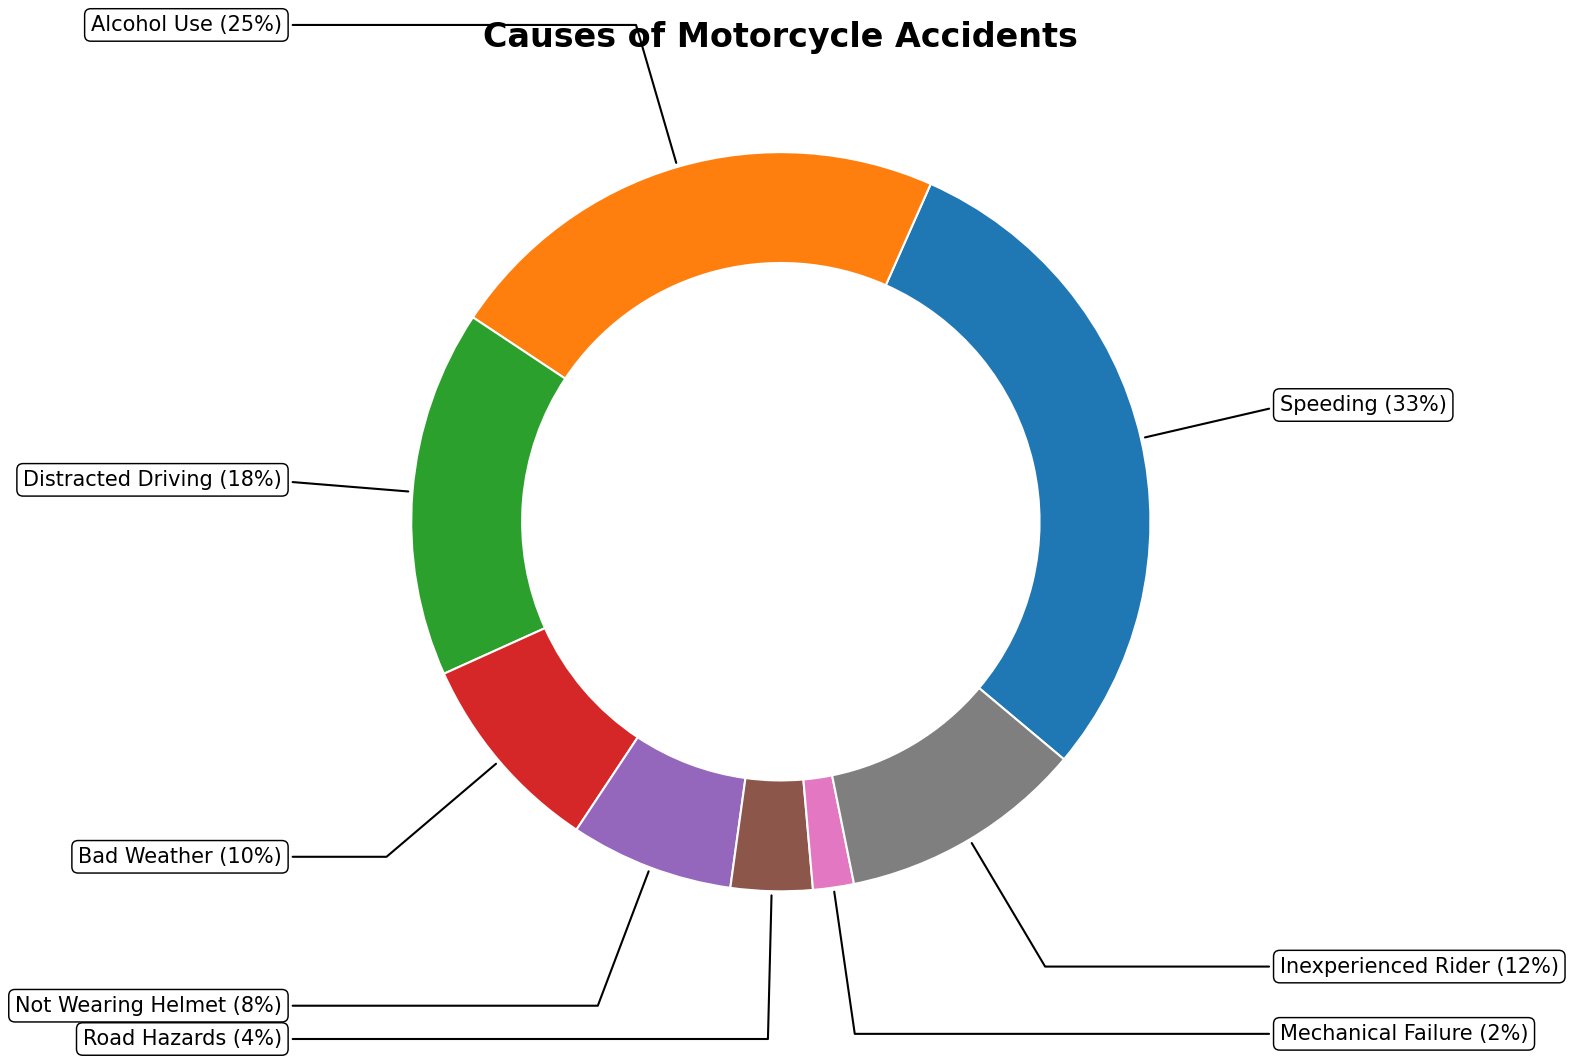What percentage of motorcycle accidents is caused by alcohol use? The segment of the chart labeled "Alcohol Use" represents the portion of accidents caused by alcohol use. According to the figure, this segment is marked with 25%.
Answer: 25% Which cause accounts for the highest percentage of motorcycle accidents? By examining the segments of the ring chart, the segment labeled "Speeding" occupies the largest portion. It is annotated with 33%, signifying it has the highest percentage.
Answer: Speeding Compare the percentages of "Distracted Driving" and "Inexperienced Rider." Which one is higher? Locate the segments for "Distracted Driving" and "Inexperienced Rider" in the chart. "Distracted Driving" is marked with 18%, while "Inexperienced Rider" is marked with 12%. Therefore, "Distracted Driving" is higher.
Answer: Distracted Driving What is the combined percentage of accidents caused by "Bad Weather" and "Not Wearing Helmet"? Find the segments for "Bad Weather" and "Not Wearing Helmet" in the ring chart. "Bad Weather" is marked with 10% and "Not Wearing Helmet" with 8%. The combined percentage is 10% + 8% = 18%.
Answer: 18% Is the percentage of accidents caused by "Mechanical Failure" greater than, less than, or equal to "Road Hazards"? Identify the segments for "Mechanical Failure" and "Road Hazards". "Mechanical Failure" is marked with 2% and "Road Hazards" with 4%. Therefore, "Mechanical Failure" is less than "Road Hazards".
Answer: Less than What are the three least common causes of motorcycle accidents according to the chart? Examine the annotated percentages of all segments and identify the three smallest values. These are "Mechanical Failure" (2%), "Road Hazards" (4%), and "Not Wearing Helmet" (8%).
Answer: Mechanical Failure, Road Hazards, Not Wearing Helmet What is the difference between the percentages of "Inexperienced Rider" and "Alcohol Use"? Referring to the ring chart, "Inexperienced Rider" accounts for 12% and "Alcohol Use" for 25%. The difference between them is 25% - 12% = 13%.
Answer: 13% If the percentages of "Speeding" and "Alcohol Use" are combined, what fraction of motorcycle accidents do they account for? The chart shows that "Speeding" accounts for 33% and "Alcohol Use" for 25%. Their combined percentage is 33% + 25% = 58%. To express this as a fraction, it is 58/100, which simplifies to 29/50.
Answer: 29/50 Are the percentages of "Distracted Driving" and "Bad Weather" together greater than "Speeding"? Check the respective segments in the ring chart: "Distracted Driving" is 18% and "Bad Weather" is 10%. Their sum is 18% + 10% = 28%, which is less than "Speeding" at 33%.
Answer: No 